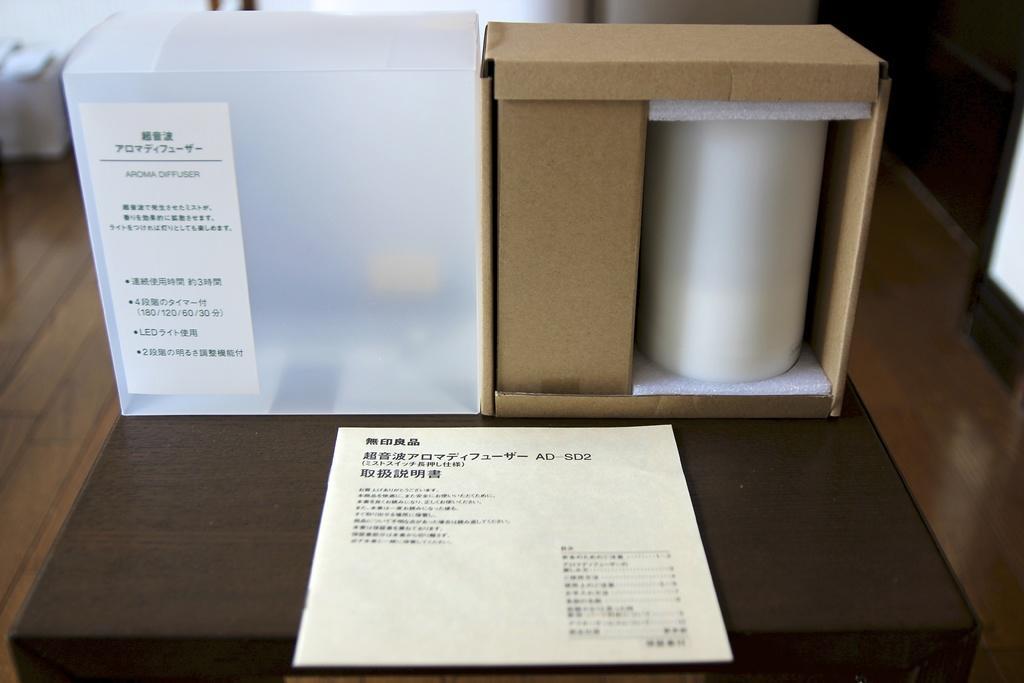In one or two sentences, can you explain what this image depicts? There are some objects and a paper is kept on a wooden surface as we can see in the middle of this image. 